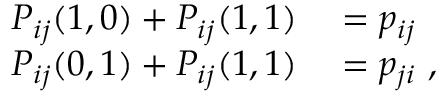Convert formula to latex. <formula><loc_0><loc_0><loc_500><loc_500>\begin{array} { r l } { P _ { i j } ( 1 , 0 ) + P _ { i j } ( 1 , 1 ) } & = p _ { i j } } \\ { P _ { i j } ( 0 , 1 ) + P _ { i j } ( 1 , 1 ) } & = p _ { j i } \ , } \end{array}</formula> 